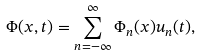<formula> <loc_0><loc_0><loc_500><loc_500>\Phi ( x , t ) = \sum _ { n = - \infty } ^ { \infty } \Phi _ { n } ( x ) u _ { n } ( t ) ,</formula> 